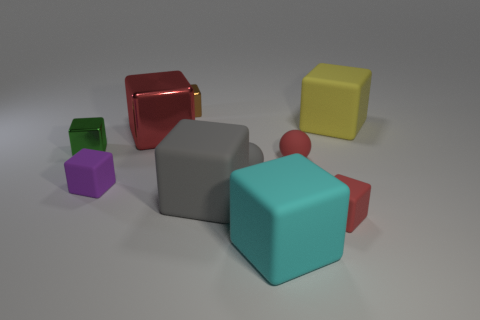Is the color of the small rubber cube that is to the right of the cyan thing the same as the big shiny cube?
Provide a short and direct response. Yes. There is a red matte sphere; what number of small purple cubes are to the right of it?
Provide a succinct answer. 0. Do the large gray block and the large block that is left of the tiny brown metal block have the same material?
Keep it short and to the point. No. There is a gray cube that is made of the same material as the small gray thing; what size is it?
Your answer should be compact. Large. Are there more rubber balls that are on the right side of the small green shiny cube than large red shiny cubes that are in front of the big cyan thing?
Offer a terse response. Yes. Is there another small metal object of the same shape as the purple thing?
Offer a very short reply. Yes. Is the size of the red cube behind the green object the same as the big yellow matte block?
Provide a short and direct response. Yes. Is there a red block?
Provide a succinct answer. Yes. What number of things are either large blocks that are right of the tiny red block or matte objects?
Provide a short and direct response. 7. There is a large metal cube; is it the same color as the small cube in front of the big gray object?
Your answer should be very brief. Yes. 